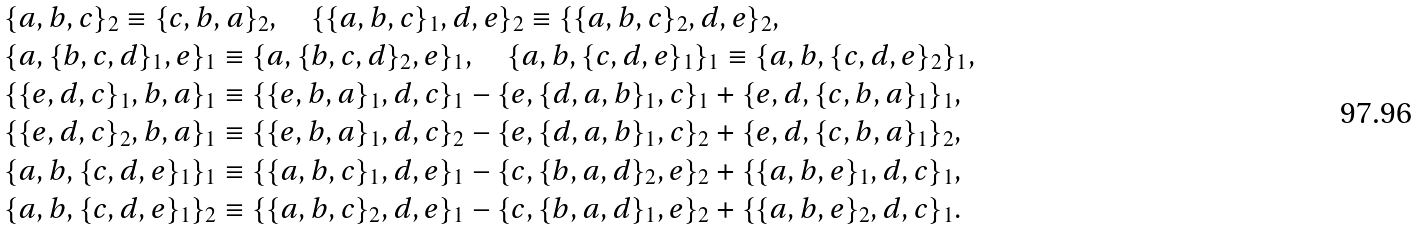Convert formula to latex. <formula><loc_0><loc_0><loc_500><loc_500>& \{ a , b , c \} _ { 2 } \equiv \{ c , b , a \} _ { 2 } , \quad \{ \{ a , b , c \} _ { 1 } , d , e \} _ { 2 } \equiv \{ \{ a , b , c \} _ { 2 } , d , e \} _ { 2 } , \\ & \{ a , \{ b , c , d \} _ { 1 } , e \} _ { 1 } \equiv \{ a , \{ b , c , d \} _ { 2 } , e \} _ { 1 } , \quad \{ a , b , \{ c , d , e \} _ { 1 } \} _ { 1 } \equiv \{ a , b , \{ c , d , e \} _ { 2 } \} _ { 1 } , \\ & \{ \{ e , d , c \} _ { 1 } , b , a \} _ { 1 } \equiv \{ \{ e , b , a \} _ { 1 } , d , c \} _ { 1 } - \{ e , \{ d , a , b \} _ { 1 } , c \} _ { 1 } + \{ e , d , \{ c , b , a \} _ { 1 } \} _ { 1 } , \\ & \{ \{ e , d , c \} _ { 2 } , b , a \} _ { 1 } \equiv \{ \{ e , b , a \} _ { 1 } , d , c \} _ { 2 } - \{ e , \{ d , a , b \} _ { 1 } , c \} _ { 2 } + \{ e , d , \{ c , b , a \} _ { 1 } \} _ { 2 } , \\ & \{ a , b , \{ c , d , e \} _ { 1 } \} _ { 1 } \equiv \{ \{ a , b , c \} _ { 1 } , d , e \} _ { 1 } - \{ c , \{ b , a , d \} _ { 2 } , e \} _ { 2 } + \{ \{ a , b , e \} _ { 1 } , d , c \} _ { 1 } , \\ & \{ a , b , \{ c , d , e \} _ { 1 } \} _ { 2 } \equiv \{ \{ a , b , c \} _ { 2 } , d , e \} _ { 1 } - \{ c , \{ b , a , d \} _ { 1 } , e \} _ { 2 } + \{ \{ a , b , e \} _ { 2 } , d , c \} _ { 1 } .</formula> 